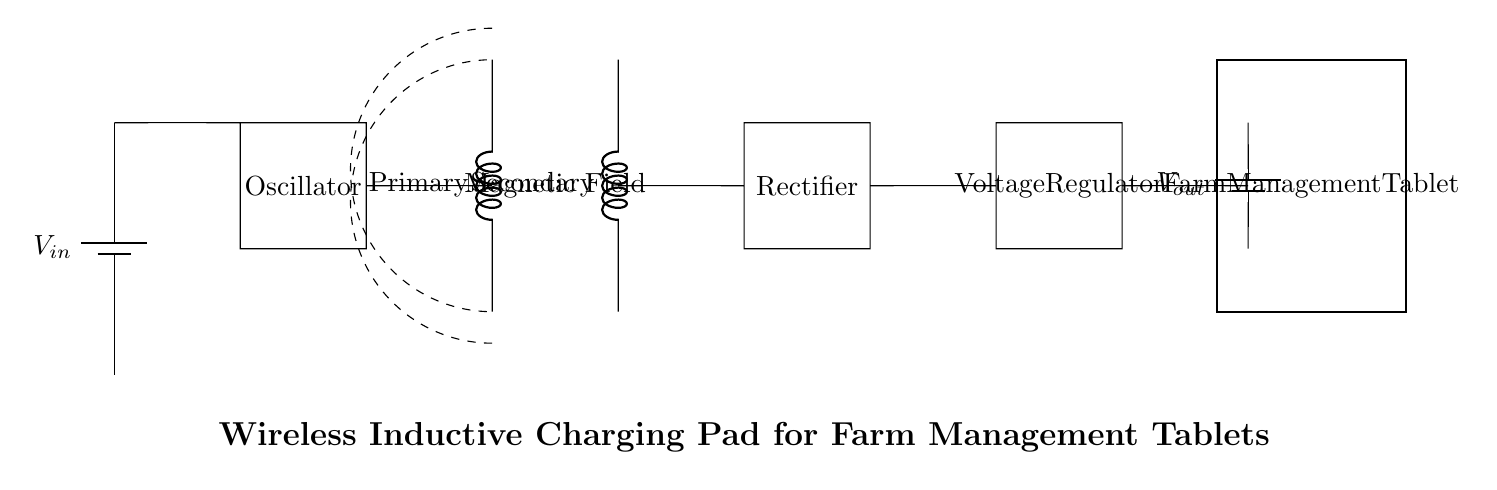What is the input voltage in the circuit? The circuit indicates a battery labeled as V_in at the left side, which is the power source providing input voltage. The specific amount is not detailed in the circuit but is signified by V_in.
Answer: V_in What is the function of the oscillator? The oscillator is a component that generates alternating current, crucial for powering the primary coil through electromagnetic induction. It converts direct current from the battery to alternating current used in the inductive charging process.
Answer: To generate alternating current What components are present in the secondary circuit? The secondary circuit includes the secondary coil, rectifier, and voltage regulator, each serving distinct functions in converting the induced voltage into usable DC voltage.
Answer: Secondary coil, rectifier, voltage regulator Which component converts alternating current to direct current? The rectifier is responsible for converting the alternating current generated by the primary coil into a direct current suitable for charging the tablet. This critical function is essential for ensuring proper charging.
Answer: Rectifier How does the magnetic field differ from the primary and secondary coils? The magnetic field is generated around the primary coil when it carries alternating current, and this field induces a voltage in the secondary coil, allowing for energy transfer without direct contact. The primary coil creates the field, while the secondary coil utilizes it.
Answer: It is created by the primary coil and used by the secondary coil 